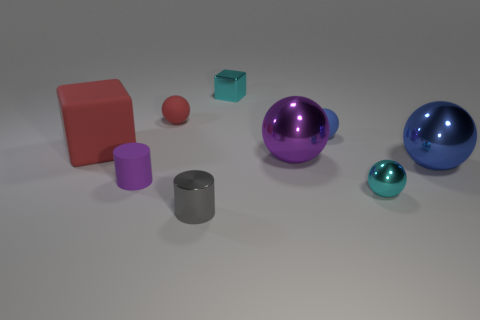Subtract all small blue spheres. How many spheres are left? 4 Subtract all red cylinders. How many blue balls are left? 2 Add 1 blue metal cylinders. How many objects exist? 10 Subtract 1 balls. How many balls are left? 4 Subtract all purple spheres. How many spheres are left? 4 Subtract all spheres. How many objects are left? 4 Subtract all gray balls. Subtract all blue cylinders. How many balls are left? 5 Subtract 0 green cubes. How many objects are left? 9 Subtract all tiny yellow rubber blocks. Subtract all large objects. How many objects are left? 6 Add 4 shiny cylinders. How many shiny cylinders are left? 5 